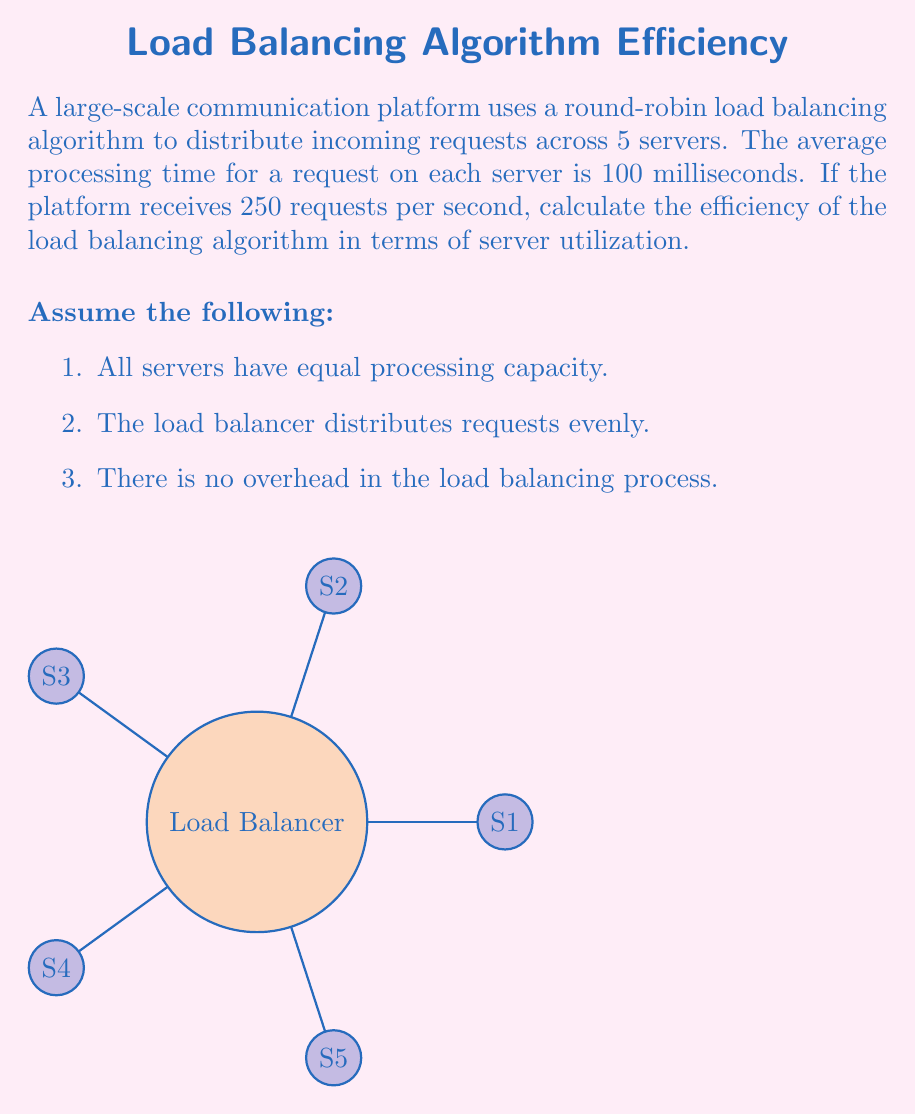What is the answer to this math problem? To calculate the efficiency of the load balancing algorithm, we need to determine the server utilization. Let's break this down step-by-step:

1. Calculate requests per server per second:
   Total requests = 250 per second
   Number of servers = 5
   Requests per server = $\frac{250}{5} = 50$ requests/second/server

2. Calculate processing time per server per second:
   Processing time per request = 100 milliseconds = 0.1 seconds
   Time spent processing per second = $50 \times 0.1 = 5$ seconds

3. Calculate server utilization:
   Server utilization = $\frac{\text{Time spent processing}}{\text{Total available time}}$
   $$ \text{Server Utilization} = \frac{5 \text{ seconds}}{1 \text{ second}} = 5 = 500\% $$

4. Interpret the result:
   A utilization of 500% means that each server is being asked to process 5 times more requests than it can handle in real-time. This indicates that the system is severely overloaded.

5. Calculate overall system efficiency:
   Ideal utilization is 100% (fully utilized but not overloaded)
   $$ \text{Efficiency} = \frac{\text{Ideal Utilization}}{\text{Actual Utilization}} \times 100\% $$
   $$ \text{Efficiency} = \frac{100\%}{500\%} \times 100\% = 20\% $$

The efficiency of the load balancing algorithm is 20%, indicating that the system is operating at only 20% of its ideal efficiency due to overloading.
Answer: 20% 